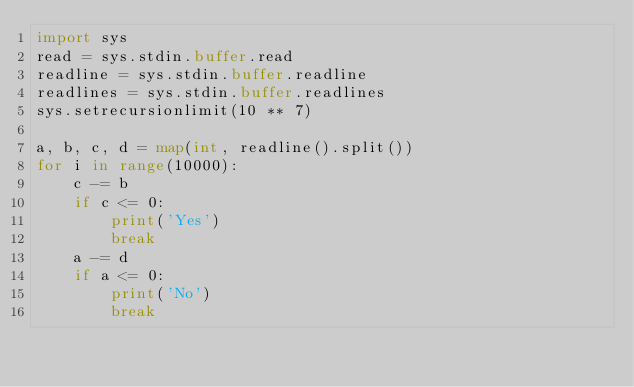<code> <loc_0><loc_0><loc_500><loc_500><_Python_>import sys
read = sys.stdin.buffer.read
readline = sys.stdin.buffer.readline
readlines = sys.stdin.buffer.readlines
sys.setrecursionlimit(10 ** 7)

a, b, c, d = map(int, readline().split())
for i in range(10000):
    c -= b
    if c <= 0:
        print('Yes')
        break
    a -= d
    if a <= 0:
        print('No')
        break
</code> 